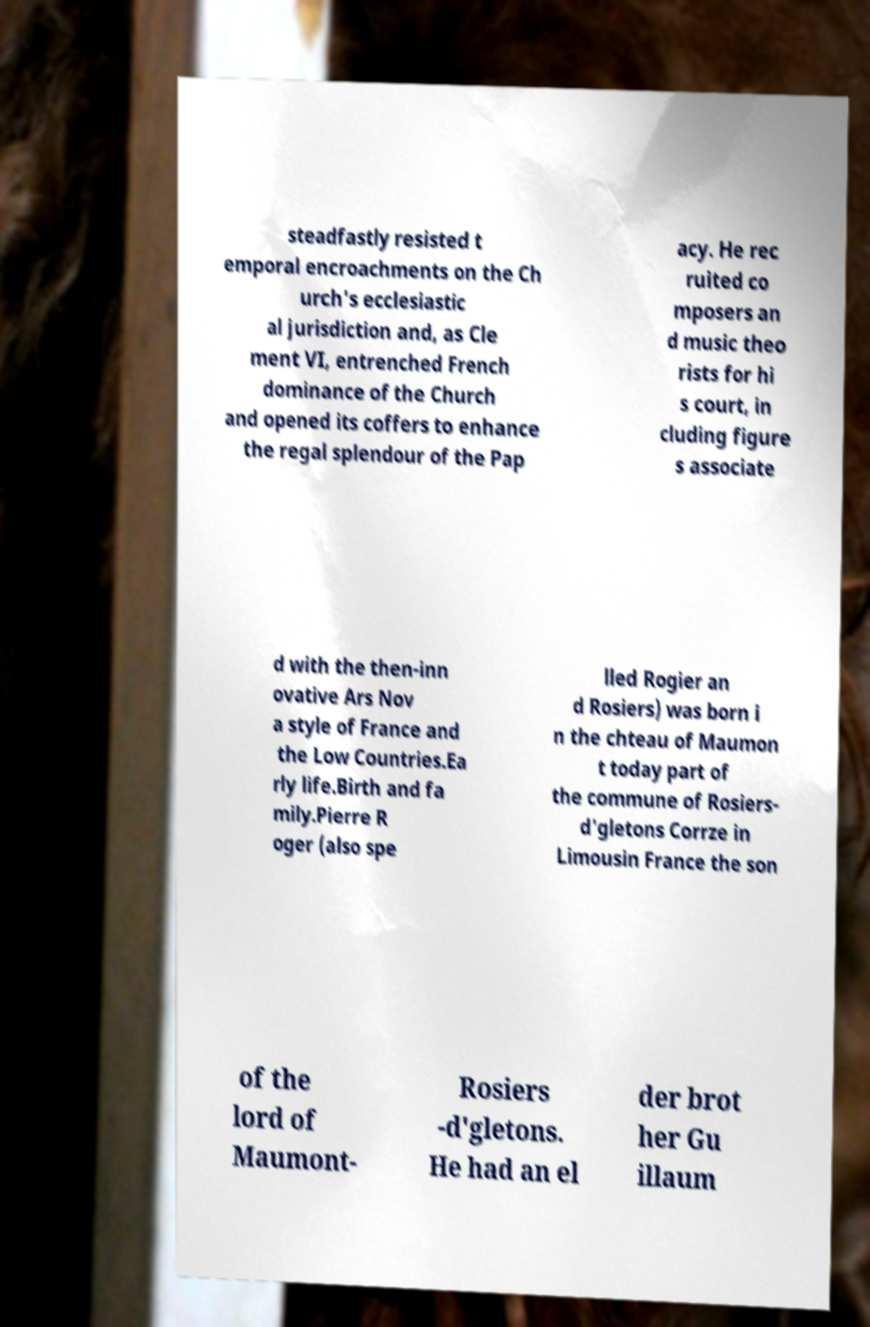For documentation purposes, I need the text within this image transcribed. Could you provide that? steadfastly resisted t emporal encroachments on the Ch urch's ecclesiastic al jurisdiction and, as Cle ment VI, entrenched French dominance of the Church and opened its coffers to enhance the regal splendour of the Pap acy. He rec ruited co mposers an d music theo rists for hi s court, in cluding figure s associate d with the then-inn ovative Ars Nov a style of France and the Low Countries.Ea rly life.Birth and fa mily.Pierre R oger (also spe lled Rogier an d Rosiers) was born i n the chteau of Maumon t today part of the commune of Rosiers- d'gletons Corrze in Limousin France the son of the lord of Maumont- Rosiers -d'gletons. He had an el der brot her Gu illaum 